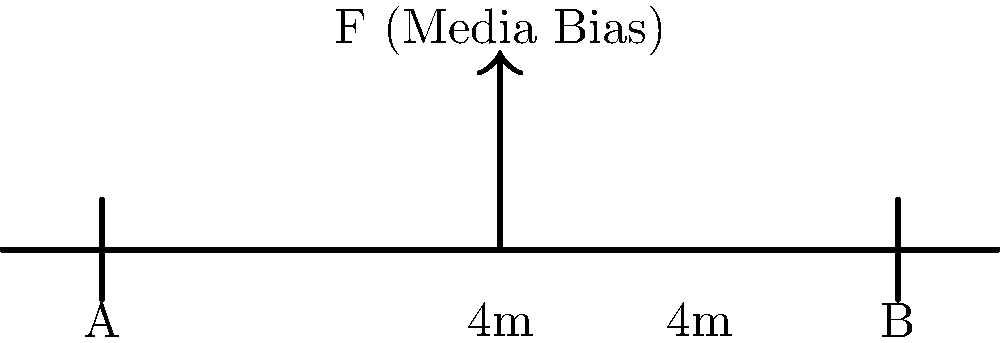In the context of media bias analysis, consider a simple beam diagram representing the balance of journalism. The beam is supported at points A and B, 8 meters apart, with a downward force F representing media bias applied at the center. If the magnitude of F is 100 N, what is the magnitude of the reaction force at support A? How does this relate to the concept of balanced reporting? To solve this problem and relate it to balanced reporting, let's follow these steps:

1) First, we need to understand that in a balanced system, the sum of all forces and moments should be zero.

2) In this case, we have a symmetrical setup with the force F applied at the center of the beam.

3) Due to symmetry, we can deduce that the reaction forces at supports A and B will be equal. Let's call each of these forces R.

4) For equilibrium of vertical forces:
   $$R_A + R_B = F$$
   $$2R = 100 N$$
   $$R = 50 N$$

5) We can verify this by taking moments about any point. Let's choose point A:
   $$F \cdot 4 - R_B \cdot 8 = 0$$
   $$100 \cdot 4 - 50 \cdot 8 = 0$$
   $$400 - 400 = 0$$

6) Relating this to balanced reporting:
   - The beam represents the spectrum of journalism.
   - The force F represents media bias trying to "bend" the truth.
   - The equal reaction forces at A and B represent the balancing forces of ethical journalism.
   - Just as the reaction forces counteract the biasing force to keep the beam level, ethical journalism practices work to counteract bias and maintain balanced reporting.

7) The magnitude of 50 N at each support shows that it takes collective effort (both sides of the journalism spectrum) to counteract bias and maintain balance.
Answer: 50 N; equal counterforces maintain journalistic balance 